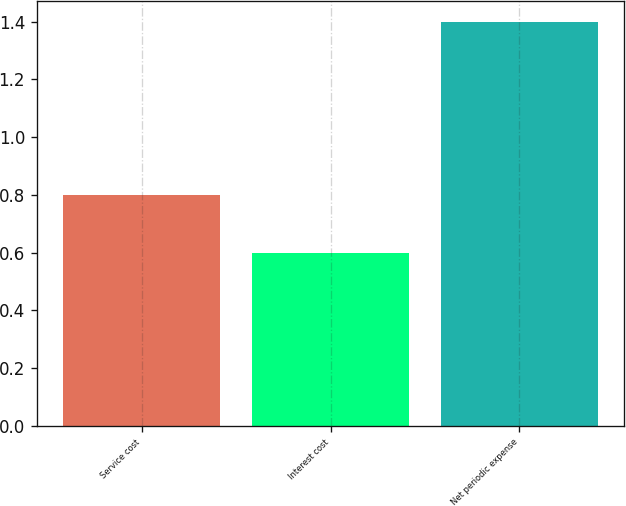Convert chart. <chart><loc_0><loc_0><loc_500><loc_500><bar_chart><fcel>Service cost<fcel>Interest cost<fcel>Net periodic expense<nl><fcel>0.8<fcel>0.6<fcel>1.4<nl></chart> 